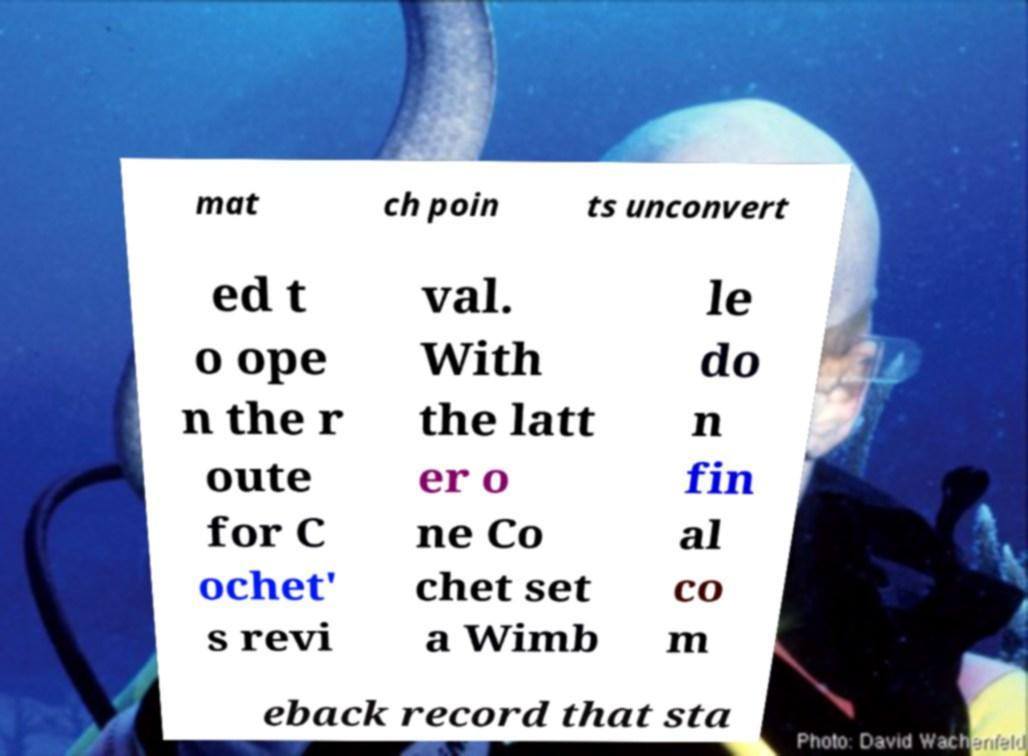There's text embedded in this image that I need extracted. Can you transcribe it verbatim? mat ch poin ts unconvert ed t o ope n the r oute for C ochet' s revi val. With the latt er o ne Co chet set a Wimb le do n fin al co m eback record that sta 